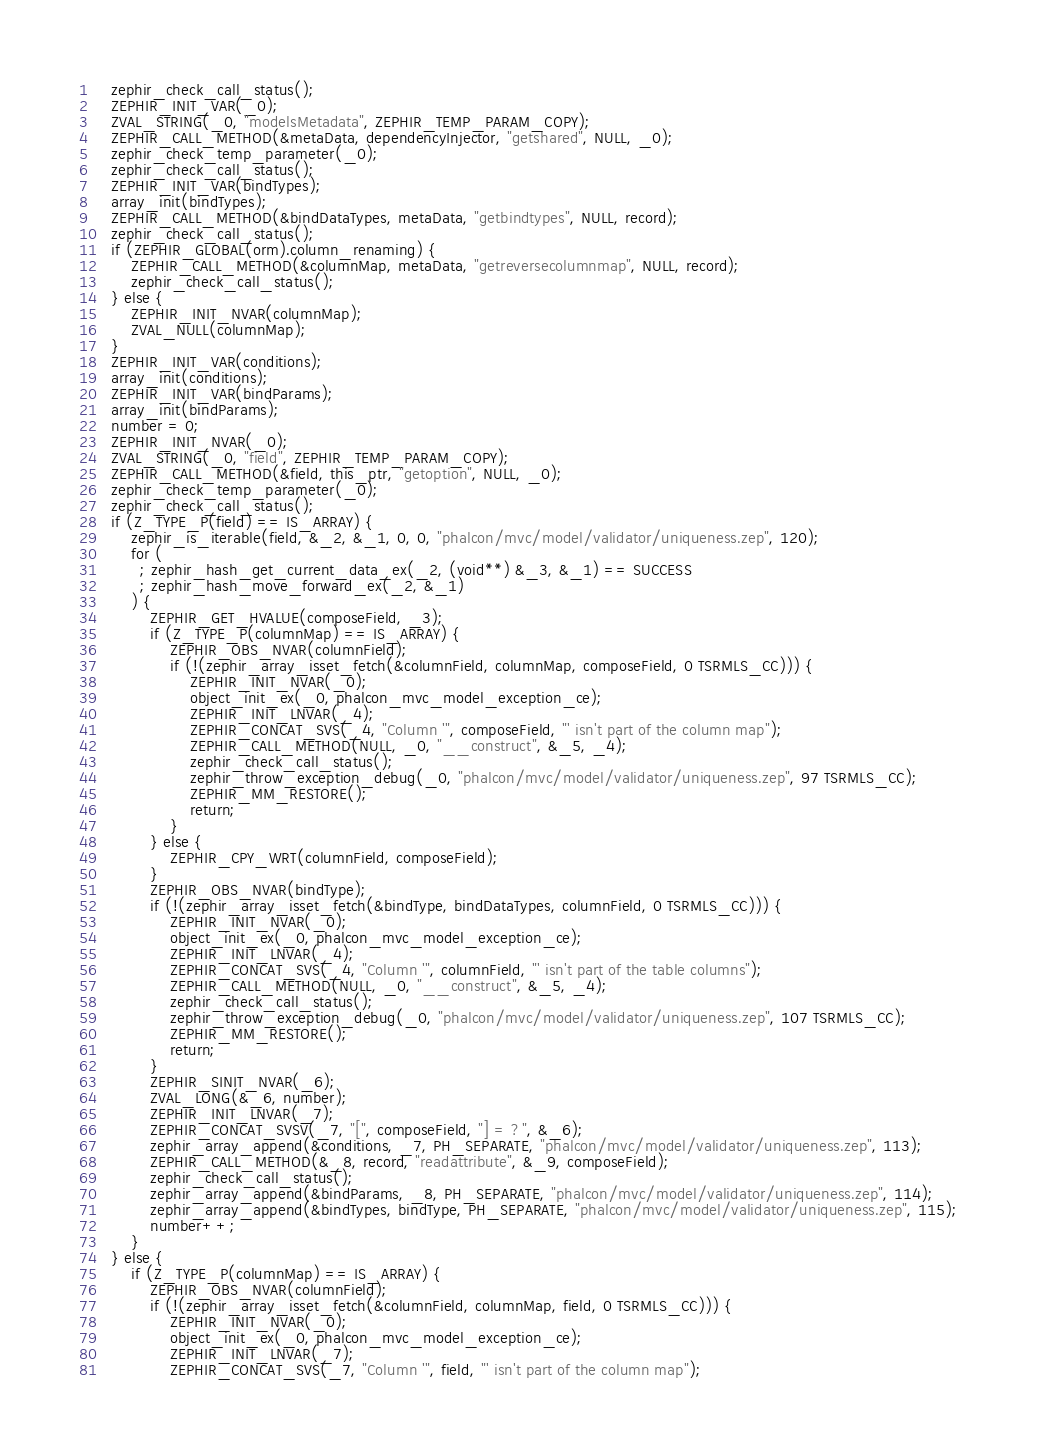Convert code to text. <code><loc_0><loc_0><loc_500><loc_500><_C_>	zephir_check_call_status();
	ZEPHIR_INIT_VAR(_0);
	ZVAL_STRING(_0, "modelsMetadata", ZEPHIR_TEMP_PARAM_COPY);
	ZEPHIR_CALL_METHOD(&metaData, dependencyInjector, "getshared", NULL, _0);
	zephir_check_temp_parameter(_0);
	zephir_check_call_status();
	ZEPHIR_INIT_VAR(bindTypes);
	array_init(bindTypes);
	ZEPHIR_CALL_METHOD(&bindDataTypes, metaData, "getbindtypes", NULL, record);
	zephir_check_call_status();
	if (ZEPHIR_GLOBAL(orm).column_renaming) {
		ZEPHIR_CALL_METHOD(&columnMap, metaData, "getreversecolumnmap", NULL, record);
		zephir_check_call_status();
	} else {
		ZEPHIR_INIT_NVAR(columnMap);
		ZVAL_NULL(columnMap);
	}
	ZEPHIR_INIT_VAR(conditions);
	array_init(conditions);
	ZEPHIR_INIT_VAR(bindParams);
	array_init(bindParams);
	number = 0;
	ZEPHIR_INIT_NVAR(_0);
	ZVAL_STRING(_0, "field", ZEPHIR_TEMP_PARAM_COPY);
	ZEPHIR_CALL_METHOD(&field, this_ptr, "getoption", NULL, _0);
	zephir_check_temp_parameter(_0);
	zephir_check_call_status();
	if (Z_TYPE_P(field) == IS_ARRAY) {
		zephir_is_iterable(field, &_2, &_1, 0, 0, "phalcon/mvc/model/validator/uniqueness.zep", 120);
		for (
		  ; zephir_hash_get_current_data_ex(_2, (void**) &_3, &_1) == SUCCESS
		  ; zephir_hash_move_forward_ex(_2, &_1)
		) {
			ZEPHIR_GET_HVALUE(composeField, _3);
			if (Z_TYPE_P(columnMap) == IS_ARRAY) {
				ZEPHIR_OBS_NVAR(columnField);
				if (!(zephir_array_isset_fetch(&columnField, columnMap, composeField, 0 TSRMLS_CC))) {
					ZEPHIR_INIT_NVAR(_0);
					object_init_ex(_0, phalcon_mvc_model_exception_ce);
					ZEPHIR_INIT_LNVAR(_4);
					ZEPHIR_CONCAT_SVS(_4, "Column '", composeField, "' isn't part of the column map");
					ZEPHIR_CALL_METHOD(NULL, _0, "__construct", &_5, _4);
					zephir_check_call_status();
					zephir_throw_exception_debug(_0, "phalcon/mvc/model/validator/uniqueness.zep", 97 TSRMLS_CC);
					ZEPHIR_MM_RESTORE();
					return;
				}
			} else {
				ZEPHIR_CPY_WRT(columnField, composeField);
			}
			ZEPHIR_OBS_NVAR(bindType);
			if (!(zephir_array_isset_fetch(&bindType, bindDataTypes, columnField, 0 TSRMLS_CC))) {
				ZEPHIR_INIT_NVAR(_0);
				object_init_ex(_0, phalcon_mvc_model_exception_ce);
				ZEPHIR_INIT_LNVAR(_4);
				ZEPHIR_CONCAT_SVS(_4, "Column '", columnField, "' isn't part of the table columns");
				ZEPHIR_CALL_METHOD(NULL, _0, "__construct", &_5, _4);
				zephir_check_call_status();
				zephir_throw_exception_debug(_0, "phalcon/mvc/model/validator/uniqueness.zep", 107 TSRMLS_CC);
				ZEPHIR_MM_RESTORE();
				return;
			}
			ZEPHIR_SINIT_NVAR(_6);
			ZVAL_LONG(&_6, number);
			ZEPHIR_INIT_LNVAR(_7);
			ZEPHIR_CONCAT_SVSV(_7, "[", composeField, "] = ?", &_6);
			zephir_array_append(&conditions, _7, PH_SEPARATE, "phalcon/mvc/model/validator/uniqueness.zep", 113);
			ZEPHIR_CALL_METHOD(&_8, record, "readattribute", &_9, composeField);
			zephir_check_call_status();
			zephir_array_append(&bindParams, _8, PH_SEPARATE, "phalcon/mvc/model/validator/uniqueness.zep", 114);
			zephir_array_append(&bindTypes, bindType, PH_SEPARATE, "phalcon/mvc/model/validator/uniqueness.zep", 115);
			number++;
		}
	} else {
		if (Z_TYPE_P(columnMap) == IS_ARRAY) {
			ZEPHIR_OBS_NVAR(columnField);
			if (!(zephir_array_isset_fetch(&columnField, columnMap, field, 0 TSRMLS_CC))) {
				ZEPHIR_INIT_NVAR(_0);
				object_init_ex(_0, phalcon_mvc_model_exception_ce);
				ZEPHIR_INIT_LNVAR(_7);
				ZEPHIR_CONCAT_SVS(_7, "Column '", field, "' isn't part of the column map");</code> 